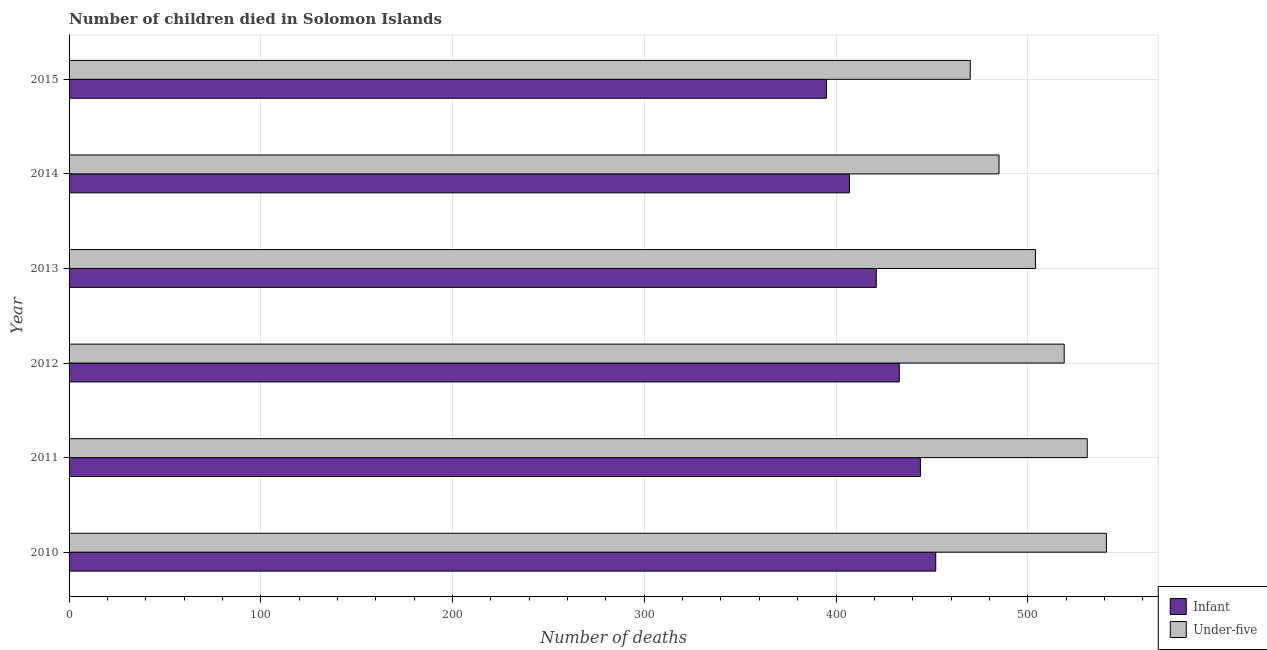Are the number of bars per tick equal to the number of legend labels?
Make the answer very short. Yes. How many bars are there on the 3rd tick from the top?
Your response must be concise. 2. How many bars are there on the 6th tick from the bottom?
Provide a succinct answer. 2. What is the label of the 4th group of bars from the top?
Make the answer very short. 2012. What is the number of infant deaths in 2013?
Offer a terse response. 421. Across all years, what is the maximum number of infant deaths?
Your response must be concise. 452. Across all years, what is the minimum number of infant deaths?
Give a very brief answer. 395. In which year was the number of infant deaths minimum?
Your response must be concise. 2015. What is the total number of under-five deaths in the graph?
Offer a very short reply. 3050. What is the difference between the number of infant deaths in 2010 and that in 2015?
Make the answer very short. 57. What is the difference between the number of infant deaths in 2015 and the number of under-five deaths in 2011?
Ensure brevity in your answer.  -136. What is the average number of under-five deaths per year?
Offer a terse response. 508.33. In the year 2013, what is the difference between the number of under-five deaths and number of infant deaths?
Offer a very short reply. 83. What is the difference between the highest and the second highest number of under-five deaths?
Ensure brevity in your answer.  10. What is the difference between the highest and the lowest number of infant deaths?
Ensure brevity in your answer.  57. In how many years, is the number of under-five deaths greater than the average number of under-five deaths taken over all years?
Your answer should be very brief. 3. What does the 2nd bar from the top in 2010 represents?
Make the answer very short. Infant. What does the 2nd bar from the bottom in 2011 represents?
Offer a very short reply. Under-five. Are all the bars in the graph horizontal?
Your answer should be compact. Yes. How many years are there in the graph?
Provide a succinct answer. 6. Does the graph contain any zero values?
Make the answer very short. No. Does the graph contain grids?
Give a very brief answer. Yes. Where does the legend appear in the graph?
Your answer should be very brief. Bottom right. How many legend labels are there?
Give a very brief answer. 2. How are the legend labels stacked?
Your answer should be compact. Vertical. What is the title of the graph?
Ensure brevity in your answer.  Number of children died in Solomon Islands. What is the label or title of the X-axis?
Provide a short and direct response. Number of deaths. What is the label or title of the Y-axis?
Your answer should be very brief. Year. What is the Number of deaths in Infant in 2010?
Provide a succinct answer. 452. What is the Number of deaths of Under-five in 2010?
Your answer should be very brief. 541. What is the Number of deaths of Infant in 2011?
Your answer should be compact. 444. What is the Number of deaths in Under-five in 2011?
Provide a short and direct response. 531. What is the Number of deaths in Infant in 2012?
Give a very brief answer. 433. What is the Number of deaths in Under-five in 2012?
Your response must be concise. 519. What is the Number of deaths in Infant in 2013?
Offer a terse response. 421. What is the Number of deaths of Under-five in 2013?
Your answer should be compact. 504. What is the Number of deaths in Infant in 2014?
Provide a short and direct response. 407. What is the Number of deaths of Under-five in 2014?
Give a very brief answer. 485. What is the Number of deaths in Infant in 2015?
Provide a succinct answer. 395. What is the Number of deaths in Under-five in 2015?
Give a very brief answer. 470. Across all years, what is the maximum Number of deaths of Infant?
Ensure brevity in your answer.  452. Across all years, what is the maximum Number of deaths of Under-five?
Ensure brevity in your answer.  541. Across all years, what is the minimum Number of deaths in Infant?
Your response must be concise. 395. Across all years, what is the minimum Number of deaths in Under-five?
Offer a very short reply. 470. What is the total Number of deaths in Infant in the graph?
Provide a short and direct response. 2552. What is the total Number of deaths in Under-five in the graph?
Offer a very short reply. 3050. What is the difference between the Number of deaths of Infant in 2010 and that in 2011?
Ensure brevity in your answer.  8. What is the difference between the Number of deaths in Under-five in 2010 and that in 2013?
Provide a short and direct response. 37. What is the difference between the Number of deaths of Infant in 2010 and that in 2014?
Offer a very short reply. 45. What is the difference between the Number of deaths in Infant in 2010 and that in 2015?
Make the answer very short. 57. What is the difference between the Number of deaths in Infant in 2011 and that in 2012?
Give a very brief answer. 11. What is the difference between the Number of deaths in Under-five in 2011 and that in 2012?
Provide a succinct answer. 12. What is the difference between the Number of deaths of Infant in 2011 and that in 2013?
Keep it short and to the point. 23. What is the difference between the Number of deaths in Infant in 2011 and that in 2015?
Your answer should be very brief. 49. What is the difference between the Number of deaths in Under-five in 2011 and that in 2015?
Ensure brevity in your answer.  61. What is the difference between the Number of deaths of Infant in 2012 and that in 2014?
Offer a very short reply. 26. What is the difference between the Number of deaths of Under-five in 2012 and that in 2015?
Ensure brevity in your answer.  49. What is the difference between the Number of deaths of Under-five in 2013 and that in 2014?
Give a very brief answer. 19. What is the difference between the Number of deaths in Infant in 2013 and that in 2015?
Offer a very short reply. 26. What is the difference between the Number of deaths of Under-five in 2013 and that in 2015?
Provide a short and direct response. 34. What is the difference between the Number of deaths in Under-five in 2014 and that in 2015?
Make the answer very short. 15. What is the difference between the Number of deaths in Infant in 2010 and the Number of deaths in Under-five in 2011?
Keep it short and to the point. -79. What is the difference between the Number of deaths of Infant in 2010 and the Number of deaths of Under-five in 2012?
Give a very brief answer. -67. What is the difference between the Number of deaths of Infant in 2010 and the Number of deaths of Under-five in 2013?
Provide a succinct answer. -52. What is the difference between the Number of deaths of Infant in 2010 and the Number of deaths of Under-five in 2014?
Offer a terse response. -33. What is the difference between the Number of deaths in Infant in 2011 and the Number of deaths in Under-five in 2012?
Give a very brief answer. -75. What is the difference between the Number of deaths in Infant in 2011 and the Number of deaths in Under-five in 2013?
Offer a very short reply. -60. What is the difference between the Number of deaths in Infant in 2011 and the Number of deaths in Under-five in 2014?
Your response must be concise. -41. What is the difference between the Number of deaths in Infant in 2012 and the Number of deaths in Under-five in 2013?
Your answer should be compact. -71. What is the difference between the Number of deaths in Infant in 2012 and the Number of deaths in Under-five in 2014?
Give a very brief answer. -52. What is the difference between the Number of deaths of Infant in 2012 and the Number of deaths of Under-five in 2015?
Give a very brief answer. -37. What is the difference between the Number of deaths of Infant in 2013 and the Number of deaths of Under-five in 2014?
Make the answer very short. -64. What is the difference between the Number of deaths of Infant in 2013 and the Number of deaths of Under-five in 2015?
Your response must be concise. -49. What is the difference between the Number of deaths in Infant in 2014 and the Number of deaths in Under-five in 2015?
Your answer should be compact. -63. What is the average Number of deaths of Infant per year?
Provide a short and direct response. 425.33. What is the average Number of deaths of Under-five per year?
Make the answer very short. 508.33. In the year 2010, what is the difference between the Number of deaths in Infant and Number of deaths in Under-five?
Your answer should be compact. -89. In the year 2011, what is the difference between the Number of deaths in Infant and Number of deaths in Under-five?
Your response must be concise. -87. In the year 2012, what is the difference between the Number of deaths in Infant and Number of deaths in Under-five?
Your response must be concise. -86. In the year 2013, what is the difference between the Number of deaths in Infant and Number of deaths in Under-five?
Provide a short and direct response. -83. In the year 2014, what is the difference between the Number of deaths in Infant and Number of deaths in Under-five?
Provide a succinct answer. -78. In the year 2015, what is the difference between the Number of deaths of Infant and Number of deaths of Under-five?
Provide a succinct answer. -75. What is the ratio of the Number of deaths in Under-five in 2010 to that in 2011?
Keep it short and to the point. 1.02. What is the ratio of the Number of deaths in Infant in 2010 to that in 2012?
Provide a short and direct response. 1.04. What is the ratio of the Number of deaths of Under-five in 2010 to that in 2012?
Keep it short and to the point. 1.04. What is the ratio of the Number of deaths of Infant in 2010 to that in 2013?
Make the answer very short. 1.07. What is the ratio of the Number of deaths in Under-five in 2010 to that in 2013?
Your response must be concise. 1.07. What is the ratio of the Number of deaths of Infant in 2010 to that in 2014?
Your answer should be compact. 1.11. What is the ratio of the Number of deaths in Under-five in 2010 to that in 2014?
Give a very brief answer. 1.12. What is the ratio of the Number of deaths in Infant in 2010 to that in 2015?
Ensure brevity in your answer.  1.14. What is the ratio of the Number of deaths in Under-five in 2010 to that in 2015?
Your answer should be compact. 1.15. What is the ratio of the Number of deaths of Infant in 2011 to that in 2012?
Provide a succinct answer. 1.03. What is the ratio of the Number of deaths of Under-five in 2011 to that in 2012?
Ensure brevity in your answer.  1.02. What is the ratio of the Number of deaths in Infant in 2011 to that in 2013?
Provide a succinct answer. 1.05. What is the ratio of the Number of deaths in Under-five in 2011 to that in 2013?
Ensure brevity in your answer.  1.05. What is the ratio of the Number of deaths in Infant in 2011 to that in 2014?
Offer a very short reply. 1.09. What is the ratio of the Number of deaths of Under-five in 2011 to that in 2014?
Offer a very short reply. 1.09. What is the ratio of the Number of deaths of Infant in 2011 to that in 2015?
Give a very brief answer. 1.12. What is the ratio of the Number of deaths of Under-five in 2011 to that in 2015?
Provide a succinct answer. 1.13. What is the ratio of the Number of deaths in Infant in 2012 to that in 2013?
Ensure brevity in your answer.  1.03. What is the ratio of the Number of deaths in Under-five in 2012 to that in 2013?
Keep it short and to the point. 1.03. What is the ratio of the Number of deaths in Infant in 2012 to that in 2014?
Keep it short and to the point. 1.06. What is the ratio of the Number of deaths in Under-five in 2012 to that in 2014?
Offer a very short reply. 1.07. What is the ratio of the Number of deaths of Infant in 2012 to that in 2015?
Make the answer very short. 1.1. What is the ratio of the Number of deaths in Under-five in 2012 to that in 2015?
Offer a very short reply. 1.1. What is the ratio of the Number of deaths of Infant in 2013 to that in 2014?
Provide a short and direct response. 1.03. What is the ratio of the Number of deaths in Under-five in 2013 to that in 2014?
Your answer should be compact. 1.04. What is the ratio of the Number of deaths in Infant in 2013 to that in 2015?
Provide a short and direct response. 1.07. What is the ratio of the Number of deaths of Under-five in 2013 to that in 2015?
Provide a short and direct response. 1.07. What is the ratio of the Number of deaths of Infant in 2014 to that in 2015?
Make the answer very short. 1.03. What is the ratio of the Number of deaths of Under-five in 2014 to that in 2015?
Provide a short and direct response. 1.03. What is the difference between the highest and the second highest Number of deaths of Under-five?
Provide a short and direct response. 10. 